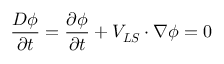Convert formula to latex. <formula><loc_0><loc_0><loc_500><loc_500>\frac { D \phi } { \partial t } = \frac { \partial \phi } { \partial t } + V _ { L S } \cdot \nabla \phi = 0</formula> 